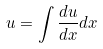<formula> <loc_0><loc_0><loc_500><loc_500>u = \int \frac { d u } { d x } d x</formula> 